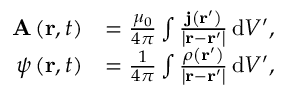<formula> <loc_0><loc_0><loc_500><loc_500>{ \begin{array} { r l } { A \left ( r , t \right ) } & { = { \frac { \mu _ { 0 } } { 4 \pi } } \int { \frac { j \left ( r ^ { \prime } \right ) } { \left | r - r ^ { \prime } \right | } } \, d V ^ { \prime } , } \\ { \psi \left ( r , t \right ) } & { = { \frac { 1 } { 4 \pi } } \int { \frac { \rho \left ( r ^ { \prime } \right ) } { \left | r - r ^ { \prime } \right | } } \, d V ^ { \prime } , } \end{array} }</formula> 